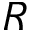<formula> <loc_0><loc_0><loc_500><loc_500>R</formula> 